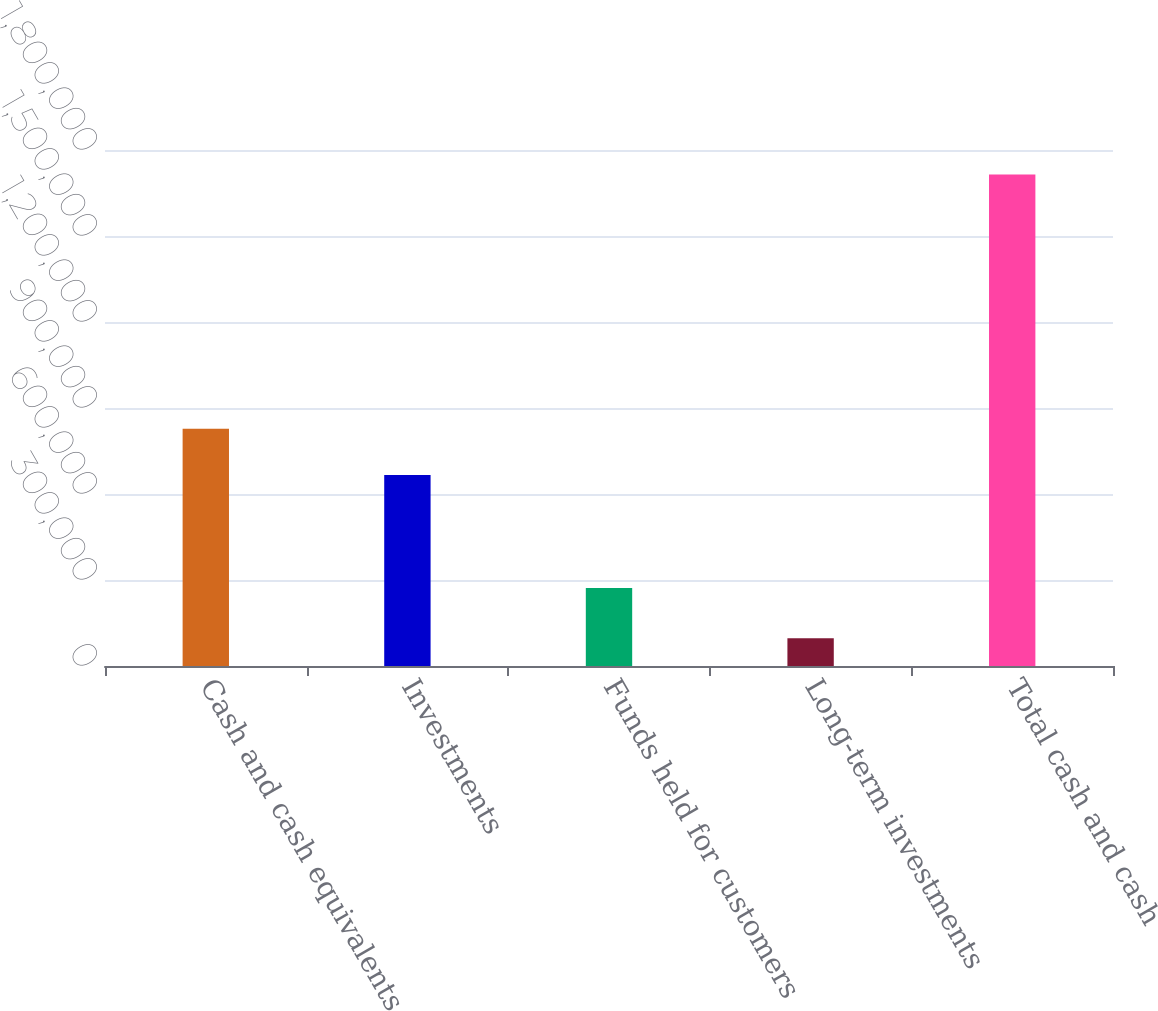Convert chart. <chart><loc_0><loc_0><loc_500><loc_500><bar_chart><fcel>Cash and cash equivalents<fcel>Investments<fcel>Funds held for customers<fcel>Long-term investments<fcel>Total cash and cash<nl><fcel>827808<fcel>666105<fcel>272028<fcel>97095<fcel>1.71413e+06<nl></chart> 